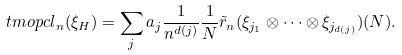Convert formula to latex. <formula><loc_0><loc_0><loc_500><loc_500>\ t m o p { c l } _ { n } ( \xi _ { H } ) = \sum _ { j } a _ { j } \frac { 1 } { n ^ { d ( j ) } } \frac { 1 } { N } \tilde { r } _ { n } ( \xi _ { j _ { 1 } } \otimes \dots \otimes \xi _ { j _ { d ( j ) } } ) ( N ) .</formula> 